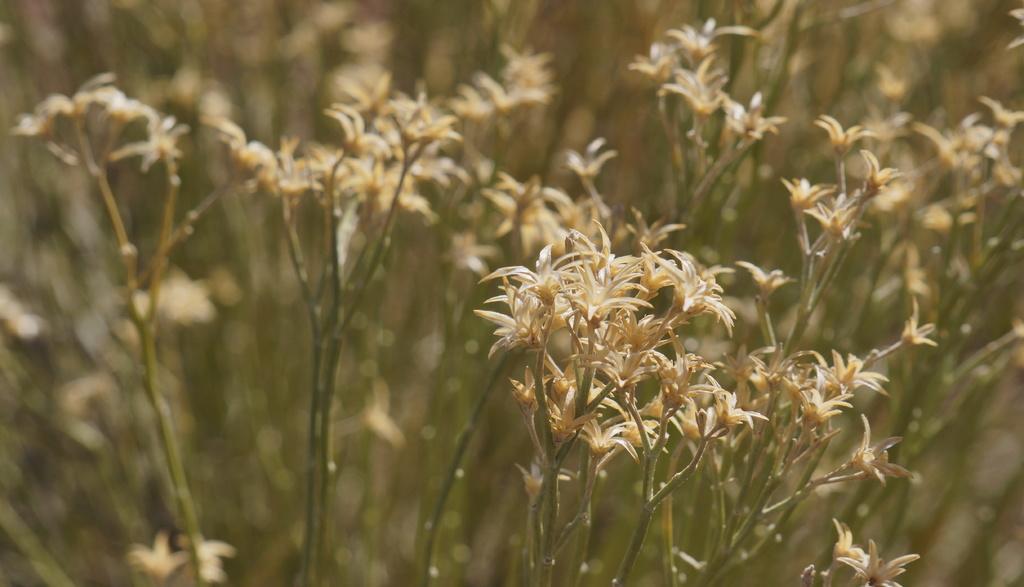In one or two sentences, can you explain what this image depicts? In this image I can see number of flowers in the front and I can see this image is little bit blurry in the background. 